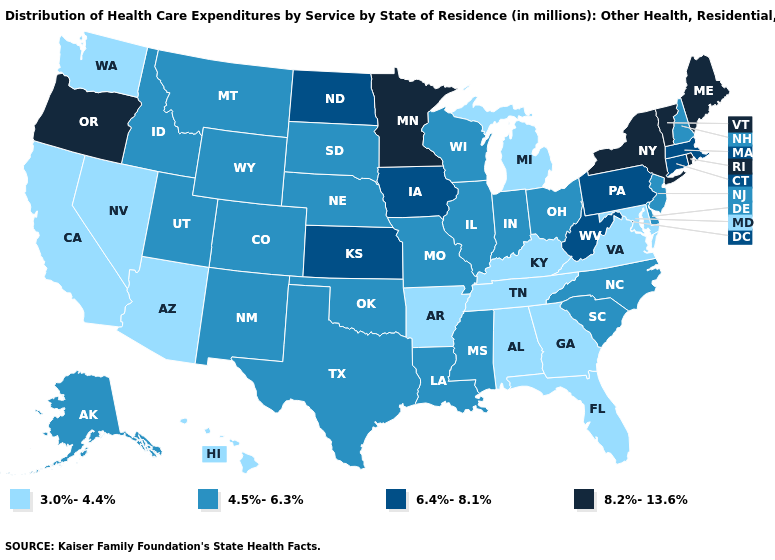Which states have the lowest value in the USA?
Write a very short answer. Alabama, Arizona, Arkansas, California, Florida, Georgia, Hawaii, Kentucky, Maryland, Michigan, Nevada, Tennessee, Virginia, Washington. What is the lowest value in states that border Maine?
Give a very brief answer. 4.5%-6.3%. What is the lowest value in the USA?
Quick response, please. 3.0%-4.4%. Which states have the lowest value in the Northeast?
Short answer required. New Hampshire, New Jersey. What is the highest value in states that border Connecticut?
Keep it brief. 8.2%-13.6%. What is the lowest value in states that border Iowa?
Write a very short answer. 4.5%-6.3%. What is the value of North Carolina?
Give a very brief answer. 4.5%-6.3%. Name the states that have a value in the range 8.2%-13.6%?
Concise answer only. Maine, Minnesota, New York, Oregon, Rhode Island, Vermont. Does Utah have a lower value than North Dakota?
Quick response, please. Yes. Does the first symbol in the legend represent the smallest category?
Give a very brief answer. Yes. Does New Mexico have the lowest value in the West?
Answer briefly. No. Does the map have missing data?
Answer briefly. No. Does New Mexico have the same value as Alabama?
Quick response, please. No. What is the lowest value in the South?
Write a very short answer. 3.0%-4.4%. Name the states that have a value in the range 4.5%-6.3%?
Be succinct. Alaska, Colorado, Delaware, Idaho, Illinois, Indiana, Louisiana, Mississippi, Missouri, Montana, Nebraska, New Hampshire, New Jersey, New Mexico, North Carolina, Ohio, Oklahoma, South Carolina, South Dakota, Texas, Utah, Wisconsin, Wyoming. 